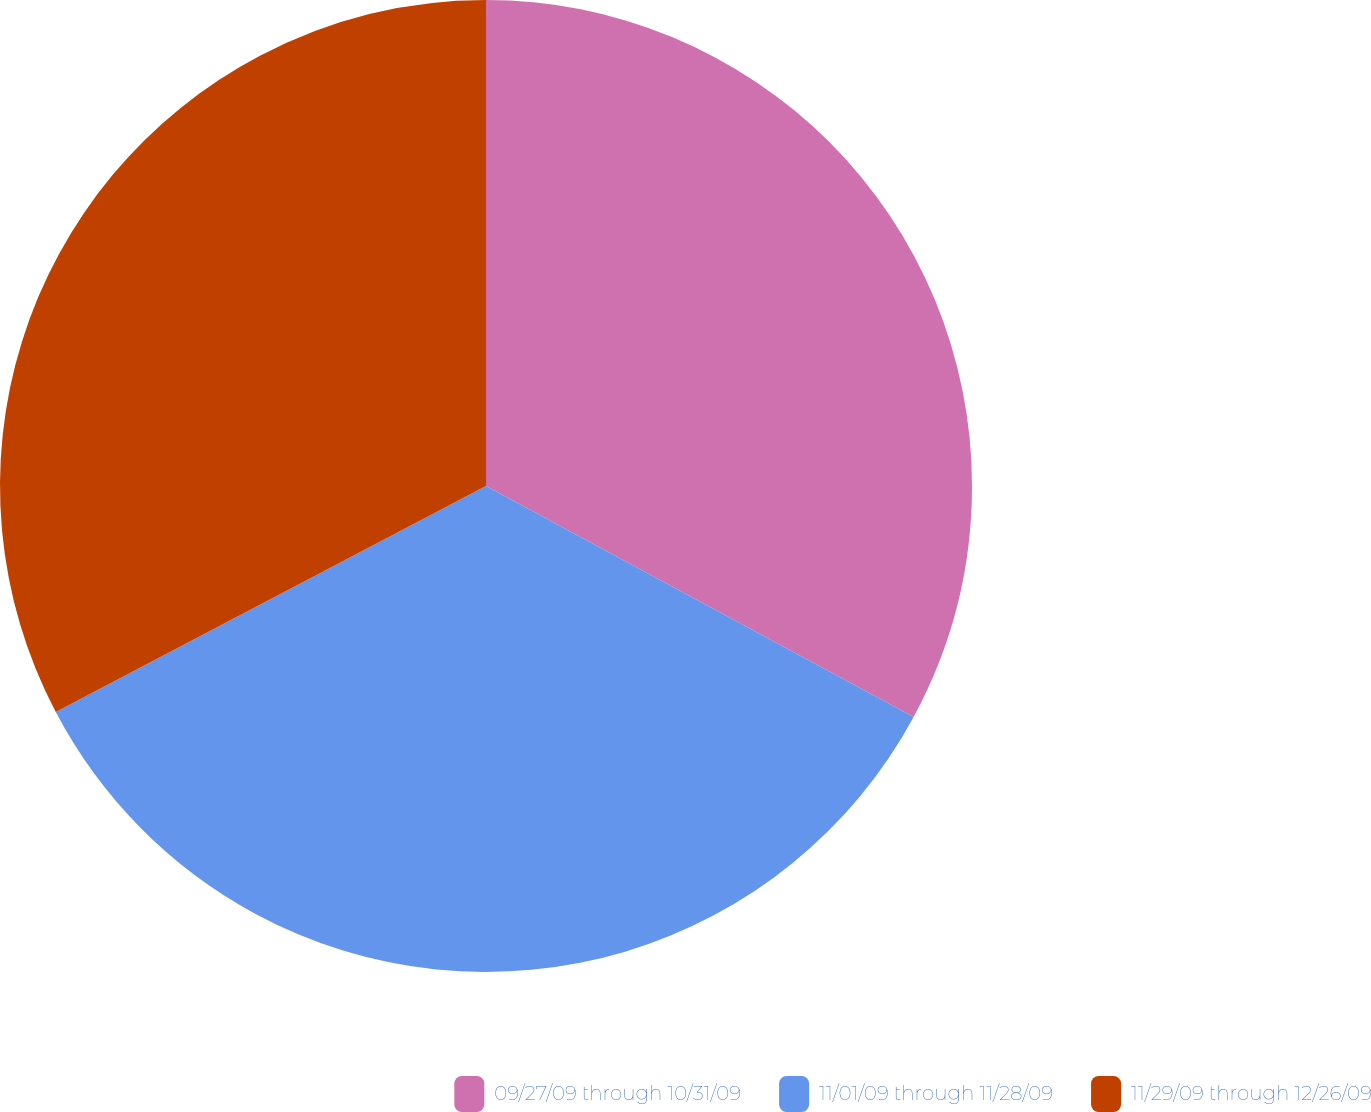Convert chart. <chart><loc_0><loc_0><loc_500><loc_500><pie_chart><fcel>09/27/09 through 10/31/09<fcel>11/01/09 through 11/28/09<fcel>11/29/09 through 12/26/09<nl><fcel>32.88%<fcel>34.42%<fcel>32.7%<nl></chart> 